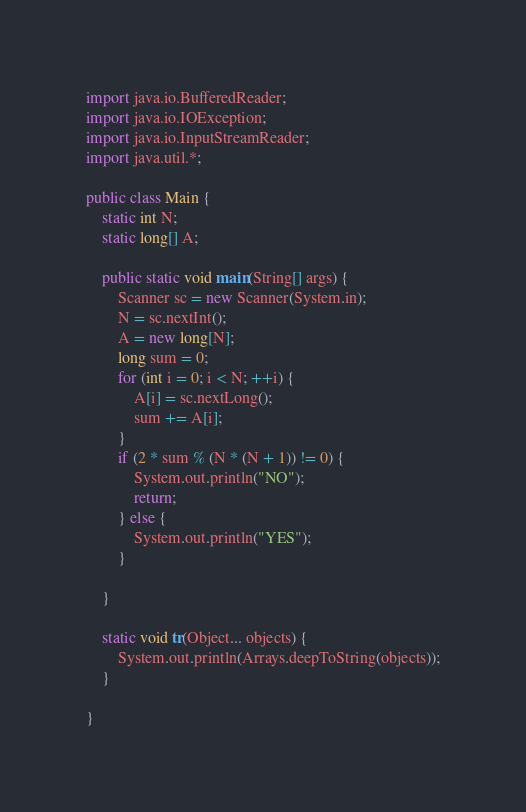Convert code to text. <code><loc_0><loc_0><loc_500><loc_500><_Java_>import java.io.BufferedReader;
import java.io.IOException;
import java.io.InputStreamReader;
import java.util.*;

public class Main {
	static int N;
	static long[] A;

	public static void main(String[] args) {
		Scanner sc = new Scanner(System.in);
		N = sc.nextInt();
		A = new long[N];
		long sum = 0;
		for (int i = 0; i < N; ++i) {
			A[i] = sc.nextLong();
			sum += A[i];
		}
		if (2 * sum % (N * (N + 1)) != 0) {
			System.out.println("NO");
			return;
		} else {
			System.out.println("YES");
		}

	}

	static void tr(Object... objects) {
		System.out.println(Arrays.deepToString(objects));
	}

}
</code> 